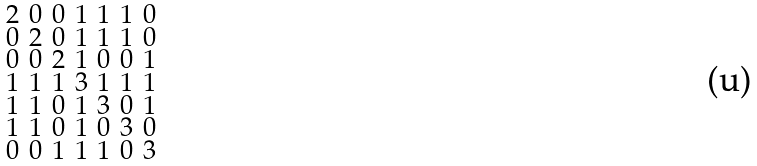Convert formula to latex. <formula><loc_0><loc_0><loc_500><loc_500>\begin{smallmatrix} 2 & 0 & 0 & 1 & 1 & 1 & 0 \\ 0 & 2 & 0 & 1 & 1 & 1 & 0 \\ 0 & 0 & 2 & 1 & 0 & 0 & 1 \\ 1 & 1 & 1 & 3 & 1 & 1 & 1 \\ 1 & 1 & 0 & 1 & 3 & 0 & 1 \\ 1 & 1 & 0 & 1 & 0 & 3 & 0 \\ 0 & 0 & 1 & 1 & 1 & 0 & 3 \end{smallmatrix}</formula> 